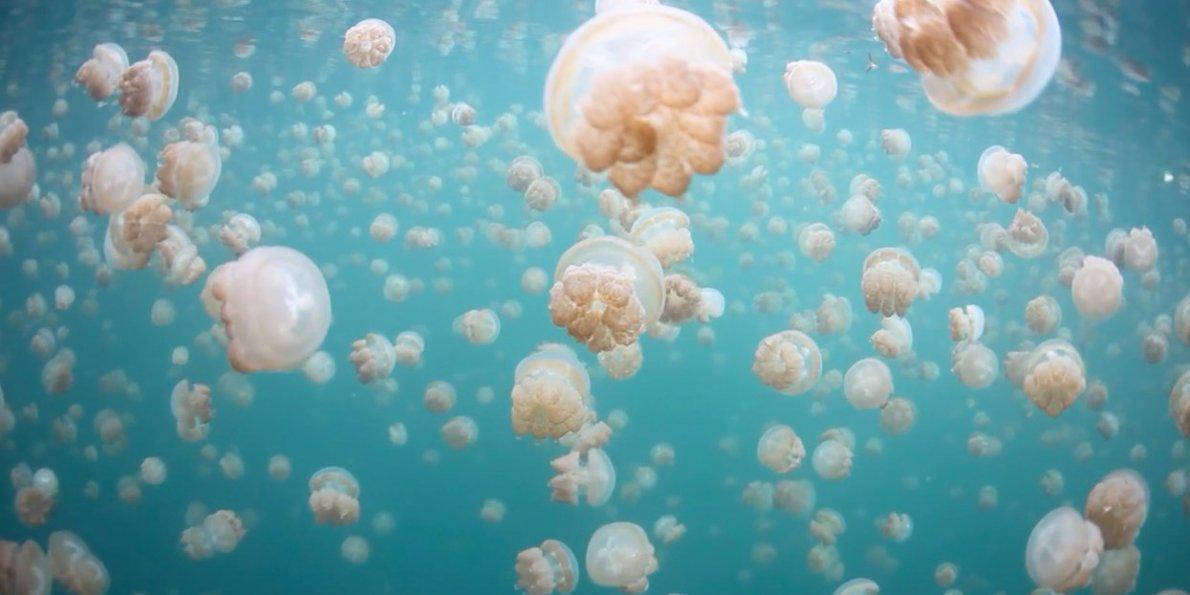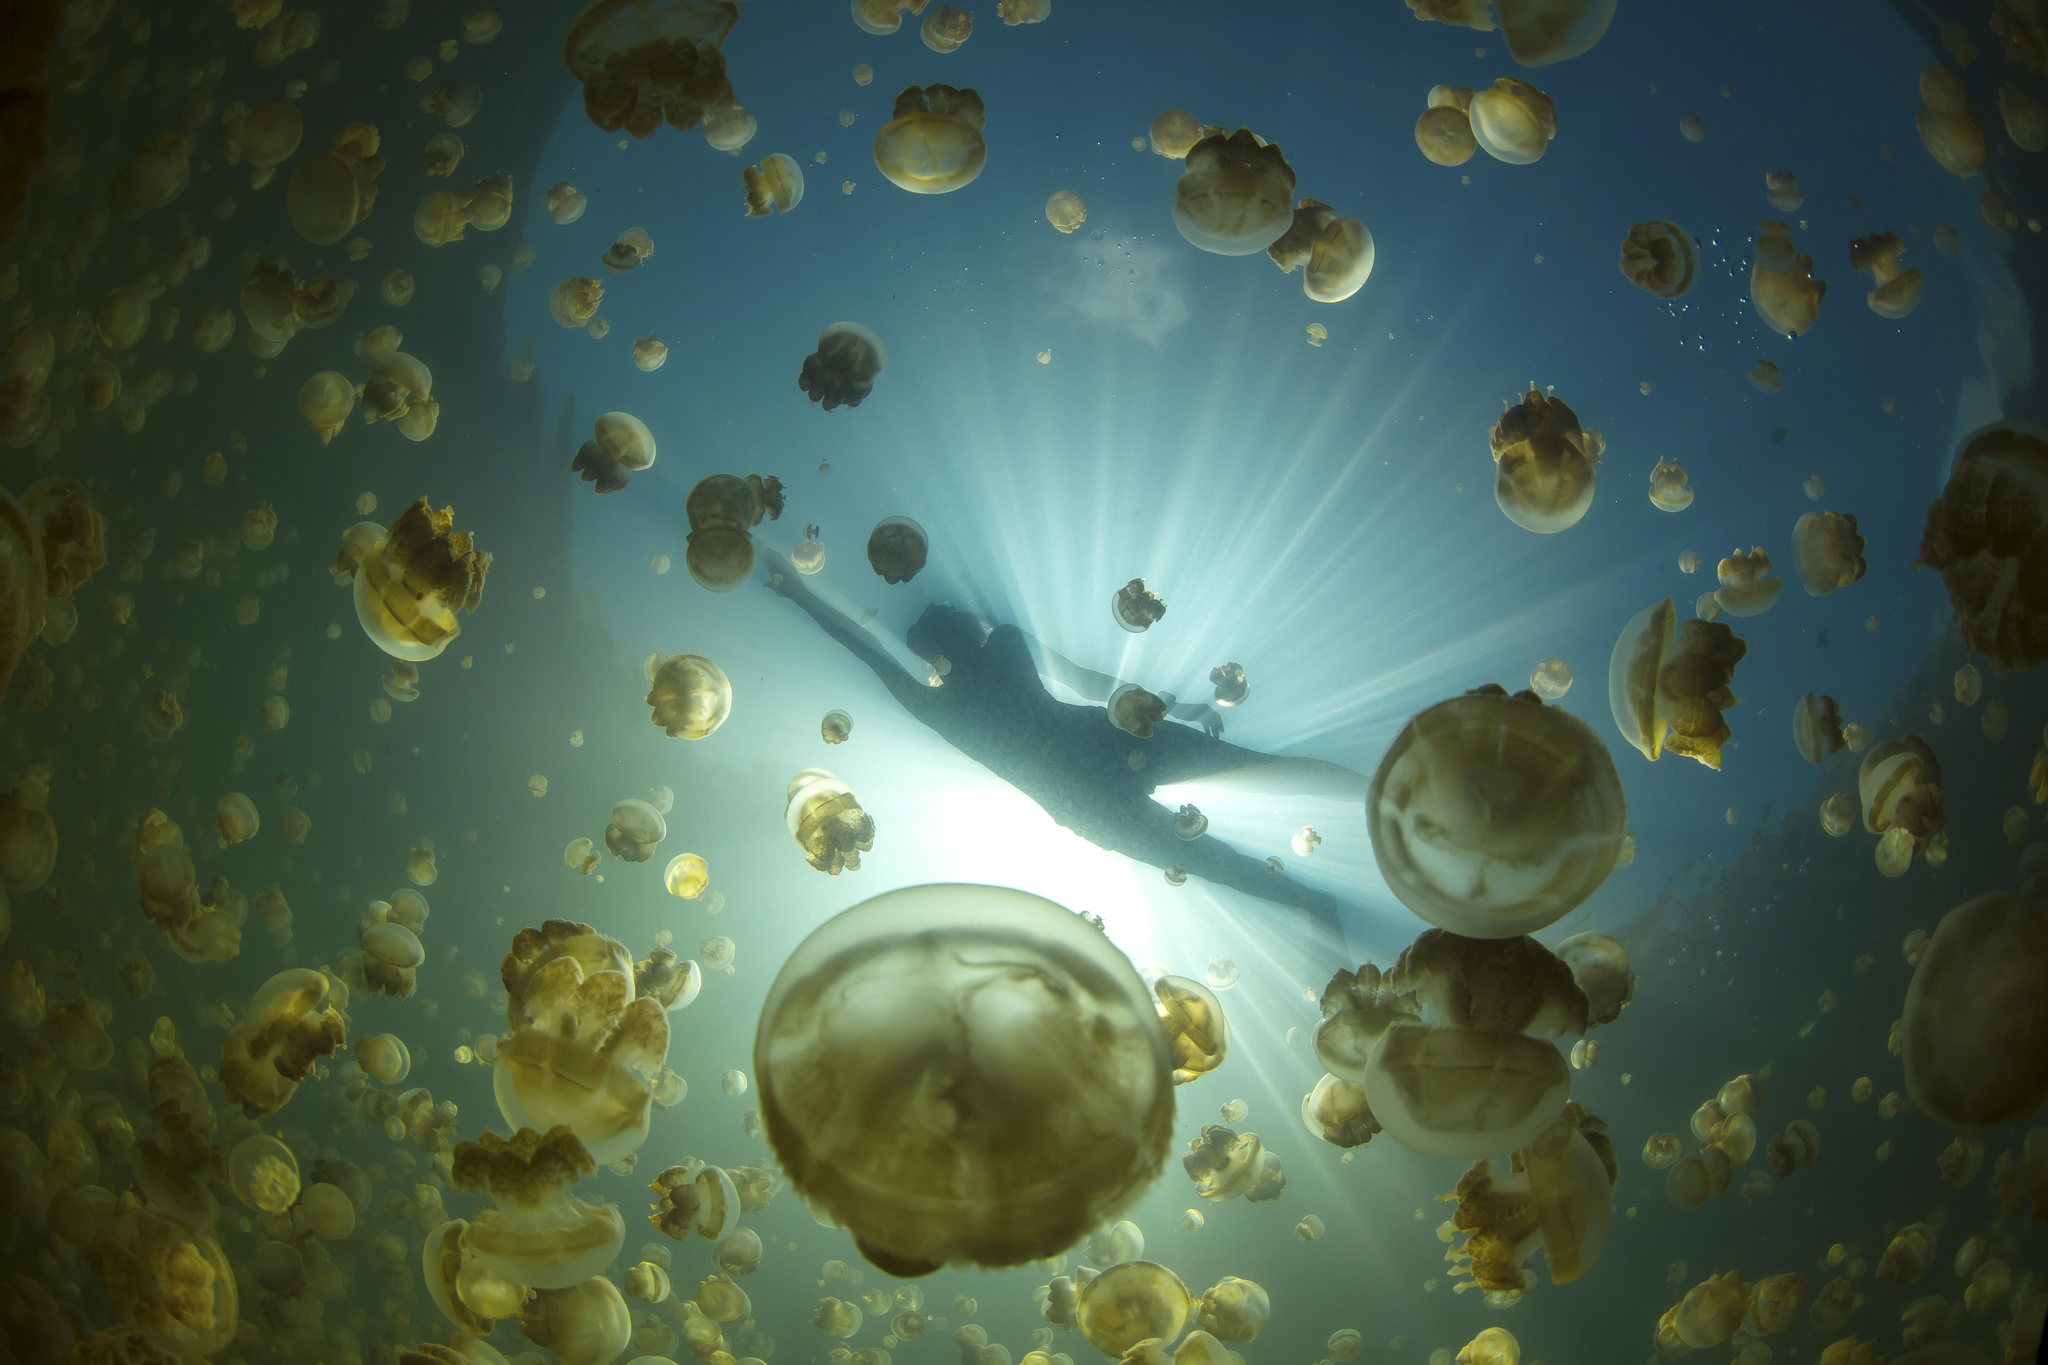The first image is the image on the left, the second image is the image on the right. Examine the images to the left and right. Is the description "At least one of the people swimming is at least partially silhouetted against the sky." accurate? Answer yes or no. Yes. The first image is the image on the left, the second image is the image on the right. Examine the images to the left and right. Is the description "There are two divers with the jellyfish." accurate? Answer yes or no. No. 